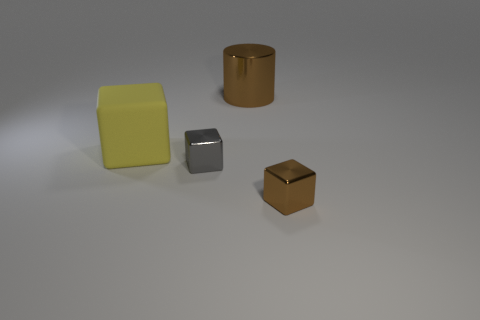There is a shiny cylinder; is it the same color as the metal block that is in front of the tiny gray cube?
Your response must be concise. Yes. There is a object that is both to the right of the gray object and behind the gray metallic cube; what is its size?
Offer a very short reply. Large. Are there any rubber cubes in front of the gray shiny cube?
Your answer should be very brief. No. Is there a metal cube behind the small metal block that is to the right of the brown cylinder?
Offer a terse response. Yes. Are there the same number of large brown things in front of the small gray metal thing and big things in front of the big yellow matte cube?
Keep it short and to the point. Yes. There is a cylinder that is the same material as the tiny brown block; what color is it?
Offer a terse response. Brown. Are there any brown blocks made of the same material as the tiny gray object?
Provide a succinct answer. Yes. What number of objects are small red metal blocks or tiny shiny objects?
Offer a very short reply. 2. Does the brown cylinder have the same material as the big object on the left side of the brown cylinder?
Your answer should be very brief. No. How big is the metallic cube left of the tiny brown metal cube?
Make the answer very short. Small. 